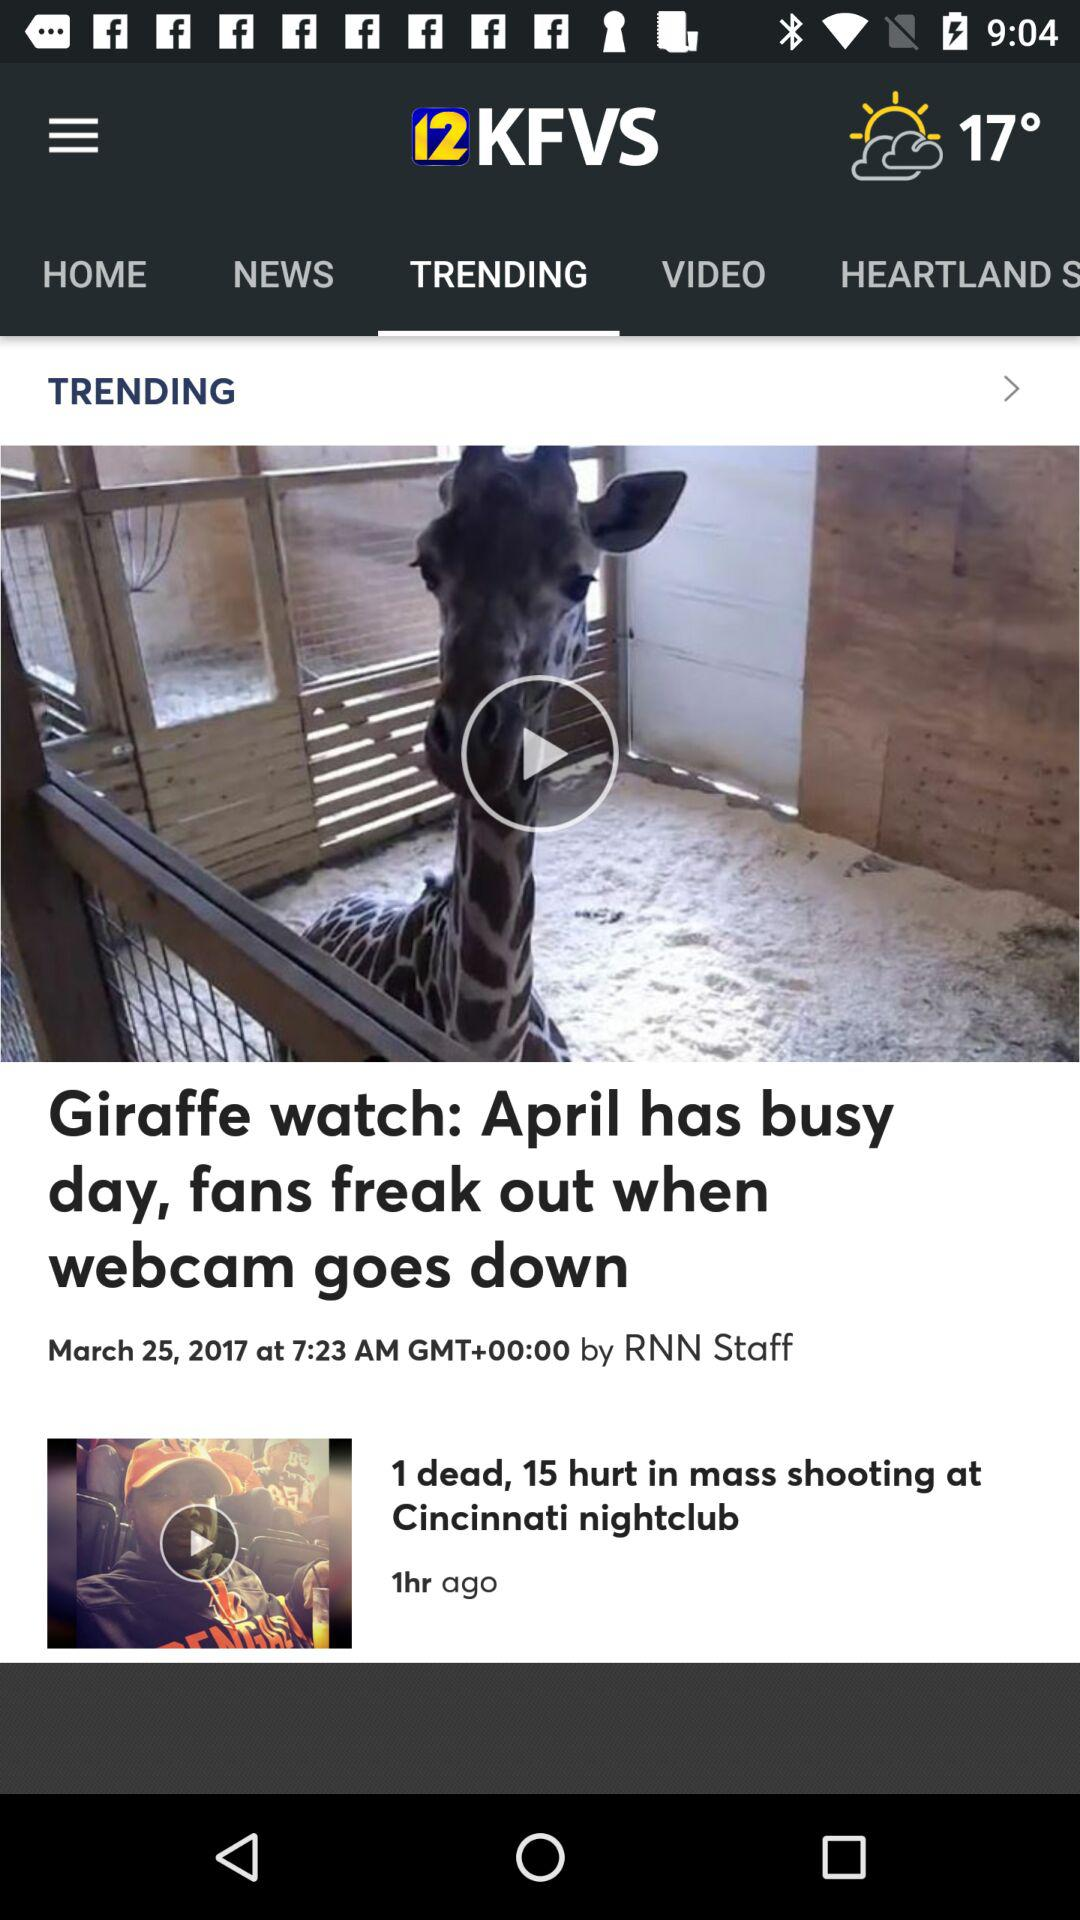On what date was the video about the giraffe watch posted? The video about the giraffe watch was posted on March 25, 2017. 